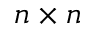<formula> <loc_0><loc_0><loc_500><loc_500>n \times n</formula> 